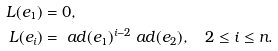<formula> <loc_0><loc_0><loc_500><loc_500>L ( e _ { 1 } ) & = 0 , \\ L ( e _ { i } ) & = \ a d ( e _ { 1 } ) ^ { i - 2 } \ a d ( e _ { 2 } ) , \quad 2 \leq i \leq n .</formula> 